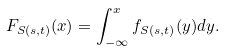Convert formula to latex. <formula><loc_0><loc_0><loc_500><loc_500>F _ { S ( s , t ) } ( x ) = \int _ { - \infty } ^ { x } f _ { S ( s , t ) } ( y ) d y .</formula> 